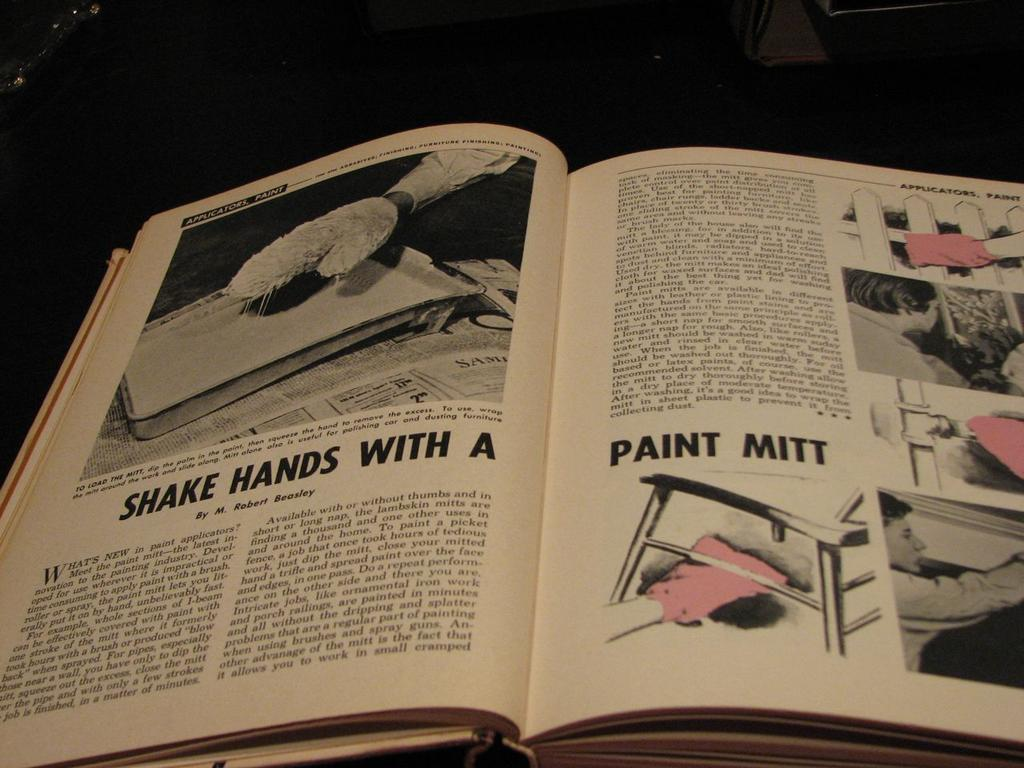<image>
Present a compact description of the photo's key features. An open book suggesting readers shake hands with a paint mitt 